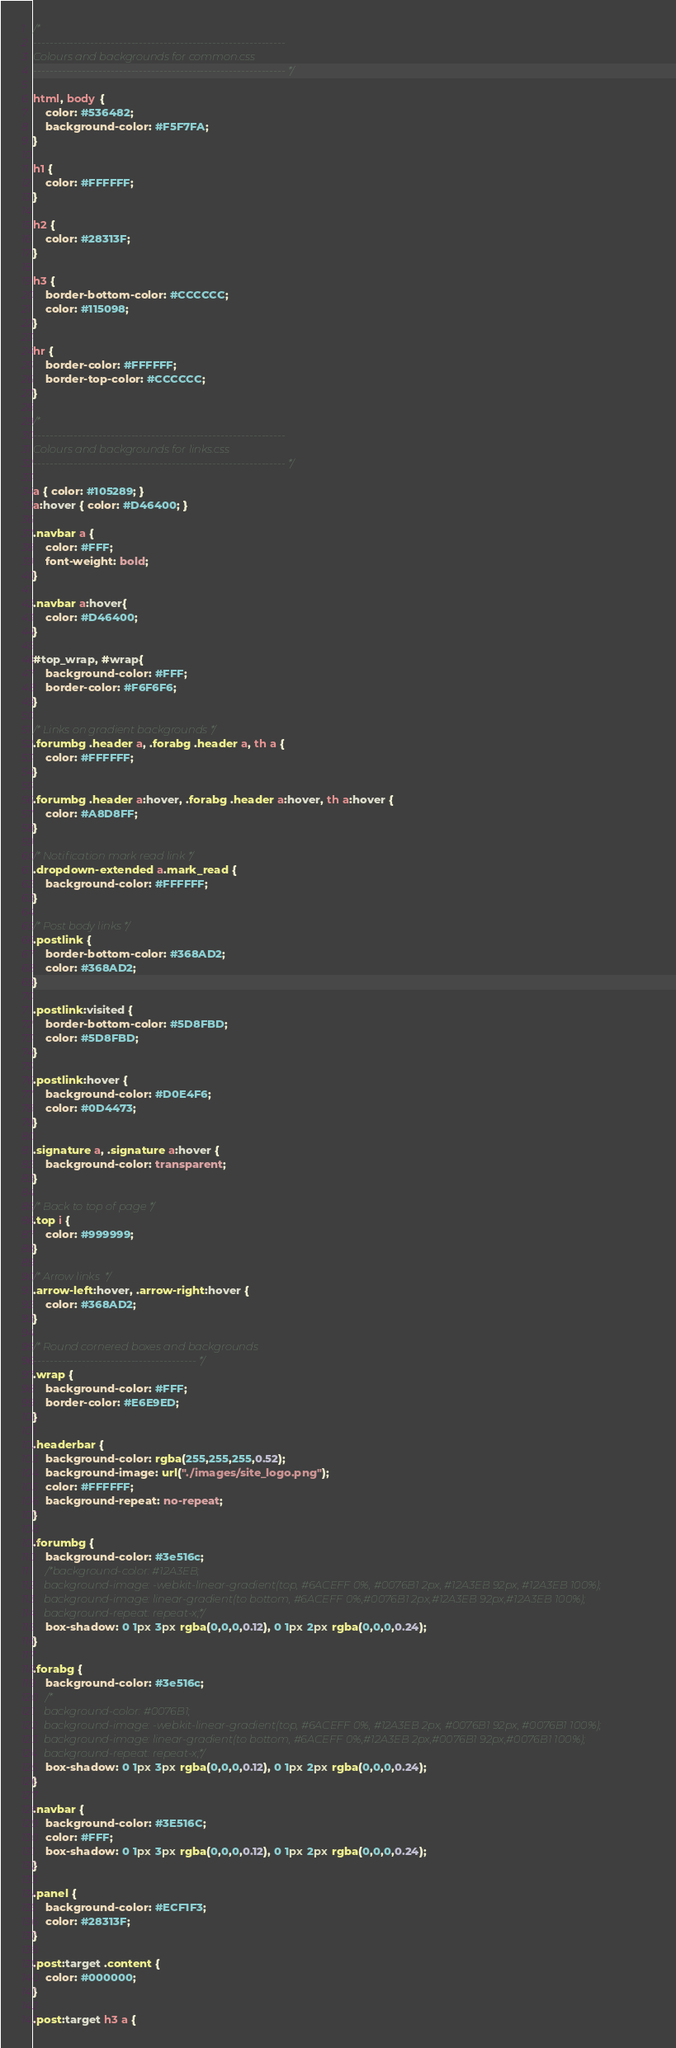<code> <loc_0><loc_0><loc_500><loc_500><_CSS_>/*
--------------------------------------------------------------
Colours and backgrounds for common.css
-------------------------------------------------------------- */

html, body {
	color: #536482;
	background-color: #F5F7FA;
}

h1 {
	color: #FFFFFF;
}

h2 {
	color: #28313F;
}

h3 {
	border-bottom-color: #CCCCCC;
	color: #115098;
}

hr {
	border-color: #FFFFFF;
	border-top-color: #CCCCCC;
}

/*
--------------------------------------------------------------
Colours and backgrounds for links.css
-------------------------------------------------------------- */

a { color: #105289; }
a:hover { color: #D46400; }

.navbar a {
    color: #FFF;
    font-weight: bold;
}

.navbar a:hover{
	color: #D46400;
}

#top_wrap, #wrap{
	background-color: #FFF;
	border-color: #F6F6F6;
}

/* Links on gradient backgrounds */
.forumbg .header a, .forabg .header a, th a {
	color: #FFFFFF;
}

.forumbg .header a:hover, .forabg .header a:hover, th a:hover {
	color: #A8D8FF;
}

/* Notification mark read link */
.dropdown-extended a.mark_read {
	background-color: #FFFFFF;
}

/* Post body links */
.postlink {
	border-bottom-color: #368AD2;
	color: #368AD2;
}

.postlink:visited {
	border-bottom-color: #5D8FBD;
	color: #5D8FBD;
}

.postlink:hover {
	background-color: #D0E4F6;
	color: #0D4473;
}

.signature a, .signature a:hover {
	background-color: transparent;
}

/* Back to top of page */
.top i {
	color: #999999;
}

/* Arrow links  */
.arrow-left:hover, .arrow-right:hover {
	color: #368AD2;
}

/* Round cornered boxes and backgrounds
---------------------------------------- */
.wrap {
	background-color: #FFF;
	border-color: #E6E9ED;
}

.headerbar {
	background-color: rgba(255,255,255,0.52);
	background-image: url("./images/site_logo.png");
	color: #FFFFFF;
	background-repeat: no-repeat;
}

.forumbg {
	background-color: #3e516c;
	/*background-color: #12A3EB;
	background-image: -webkit-linear-gradient(top, #6ACEFF 0%, #0076B1 2px, #12A3EB 92px, #12A3EB 100%);
	background-image: linear-gradient(to bottom, #6ACEFF 0%,#0076B1 2px,#12A3EB 92px,#12A3EB 100%);
	background-repeat: repeat-x;*/
	box-shadow: 0 1px 3px rgba(0,0,0,0.12), 0 1px 2px rgba(0,0,0,0.24);
}

.forabg {
	background-color: #3e516c;
	/*
	background-color: #0076B1;
	background-image: -webkit-linear-gradient(top, #6ACEFF 0%, #12A3EB 2px, #0076B1 92px, #0076B1 100%);
	background-image: linear-gradient(to bottom, #6ACEFF 0%,#12A3EB 2px,#0076B1 92px,#0076B1 100%);
	background-repeat: repeat-x;*/
	box-shadow: 0 1px 3px rgba(0,0,0,0.12), 0 1px 2px rgba(0,0,0,0.24);
}

.navbar {
	background-color: #3E516C;
	color: #FFF;
	box-shadow: 0 1px 3px rgba(0,0,0,0.12), 0 1px 2px rgba(0,0,0,0.24);
}

.panel {
	background-color: #ECF1F3;
	color: #28313F;
}

.post:target .content {
	color: #000000;
}

.post:target h3 a {</code> 